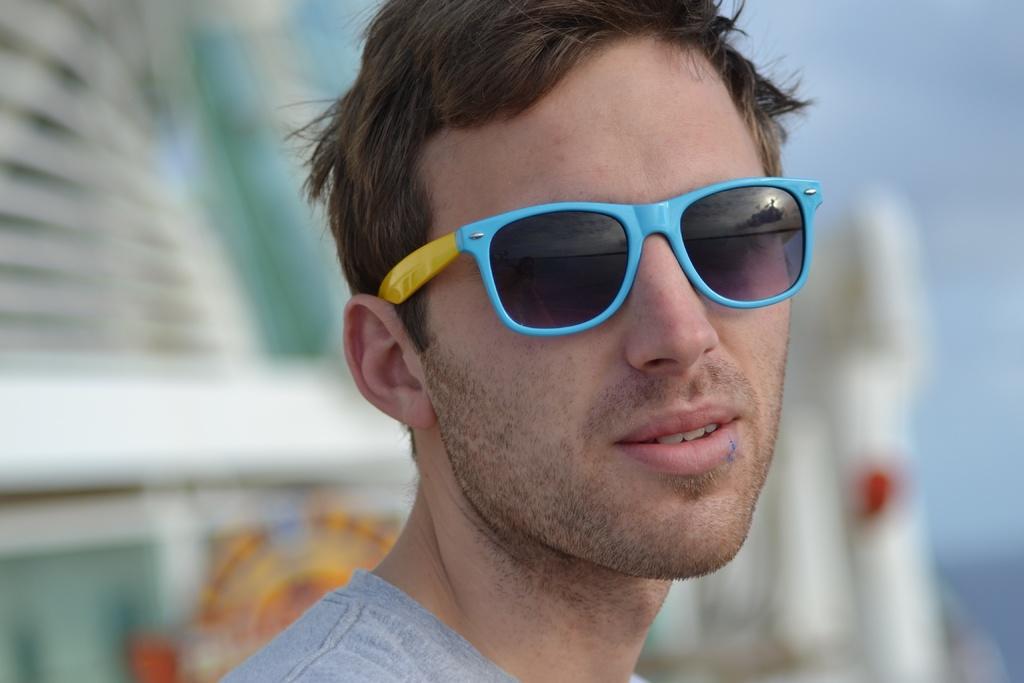In one or two sentences, can you explain what this image depicts? In this image there is a person wearing gray color shirt and blue color spectacles. And at the back there is a blur background and a sky. 